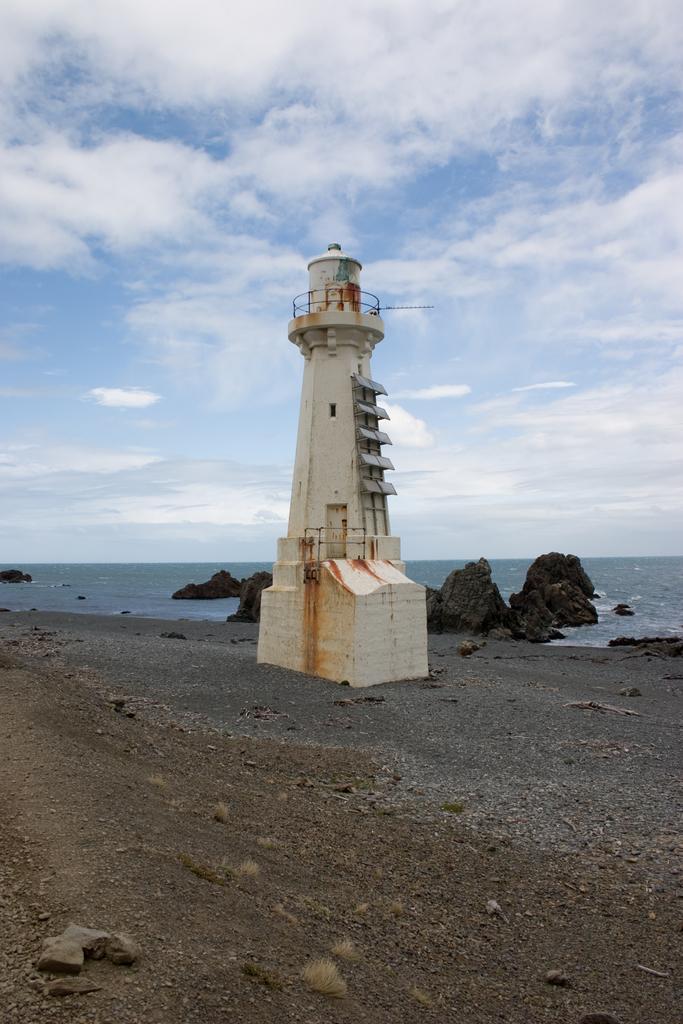Please provide a concise description of this image. This picture is taken on the seashore. In this image, in the middle, we can see a lighthouse, door. In the background, we can see some rocks in an ocean. At the top, we can see a sky which is a bit cloudy, at the bottom, we can see a land with some stones. 